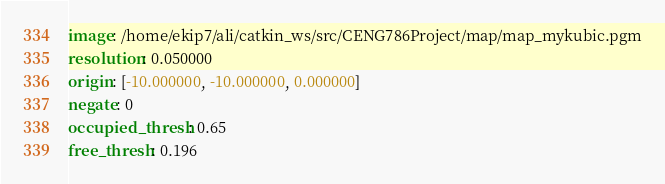<code> <loc_0><loc_0><loc_500><loc_500><_YAML_>image: /home/ekip7/ali/catkin_ws/src/CENG786Project/map/map_mykubic.pgm
resolution: 0.050000
origin: [-10.000000, -10.000000, 0.000000]
negate: 0
occupied_thresh: 0.65
free_thresh: 0.196

</code> 